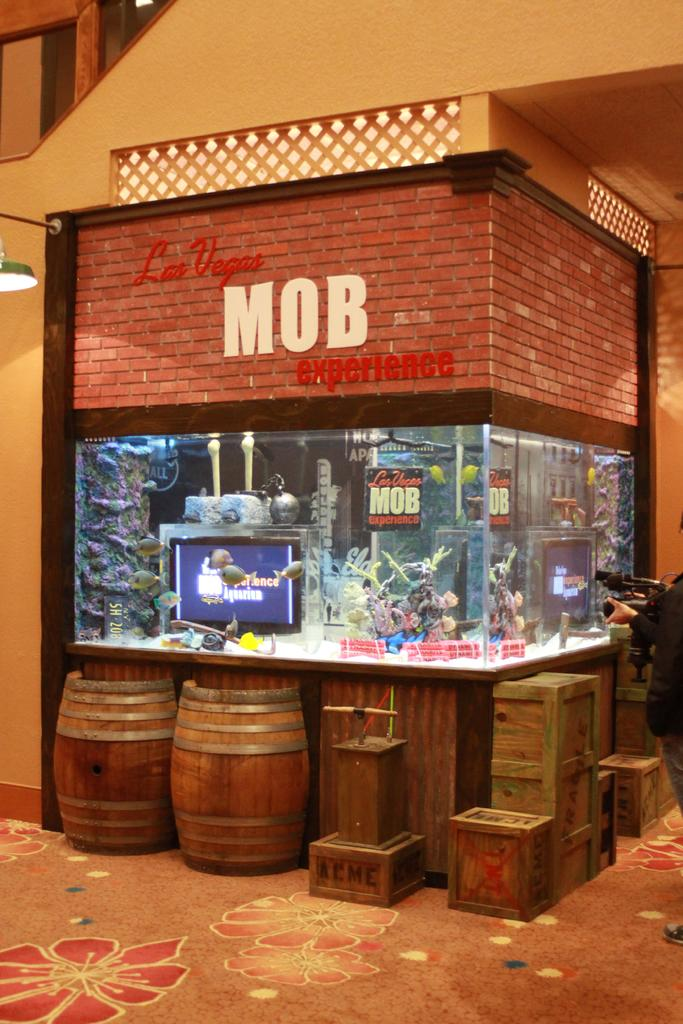What type of structure is in the image? There is a building in the image. What objects are placed in front of the building? Boxes and drums are visible in front of the building. Where are the boxes and drums located? The boxes and drums are kept on the floor. What type of cable is being used to support the building in the image? There is no cable visible in the image, and the building does not appear to be supported by any cable. 